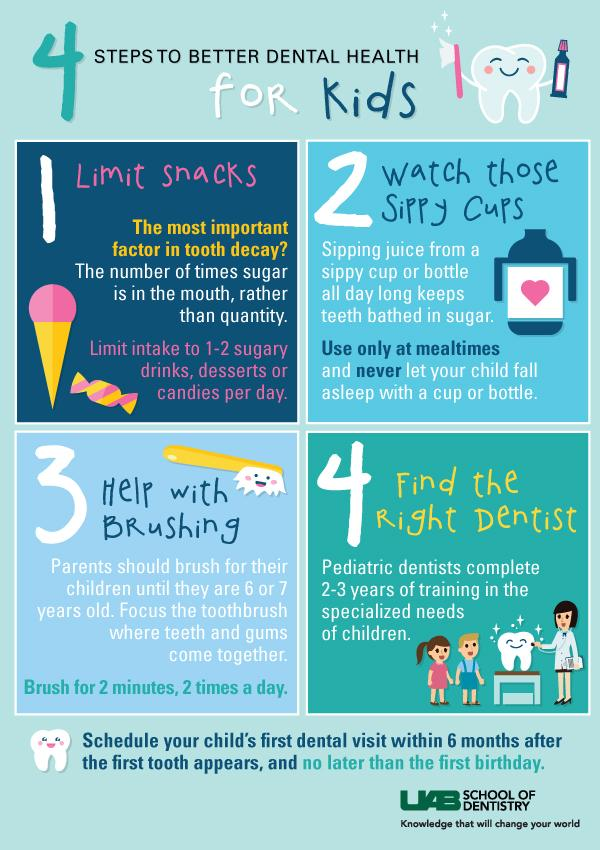Identify some key points in this picture. According to the recommendations listed in the infographic, a child should have their first dental visit after the appearance of their first tooth. It is recommended that children brush their teeth for a total of four minutes per day. 